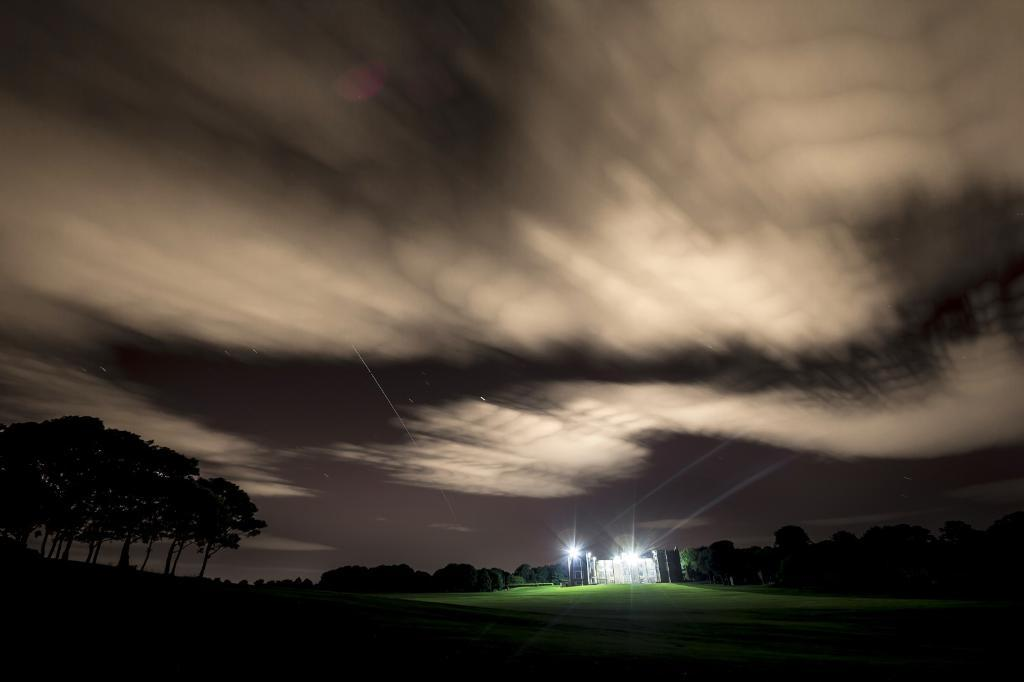What type of structure is present in the image? There is a building in the image. What other natural elements can be seen in the image? There are trees in the image. How would you describe the weather based on the image? The sky is cloudy in the image, suggesting overcast or potentially rainy weather. Are there any features of the building highlighted in the image? Yes, there are lights on the building, which may indicate that it is illuminated or has specific areas of focus. How many girls are celebrating the holiday with credit cards in the image? There are no girls, credit cards, or holidays mentioned or depicted in the image. 